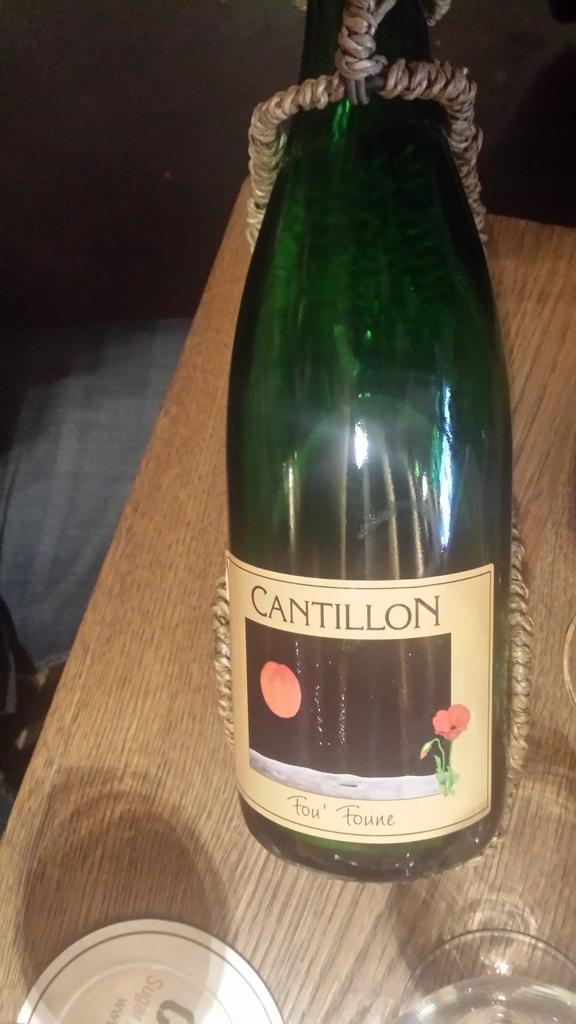<image>
Share a concise interpretation of the image provided. the word cantillon is on a wine bottle 